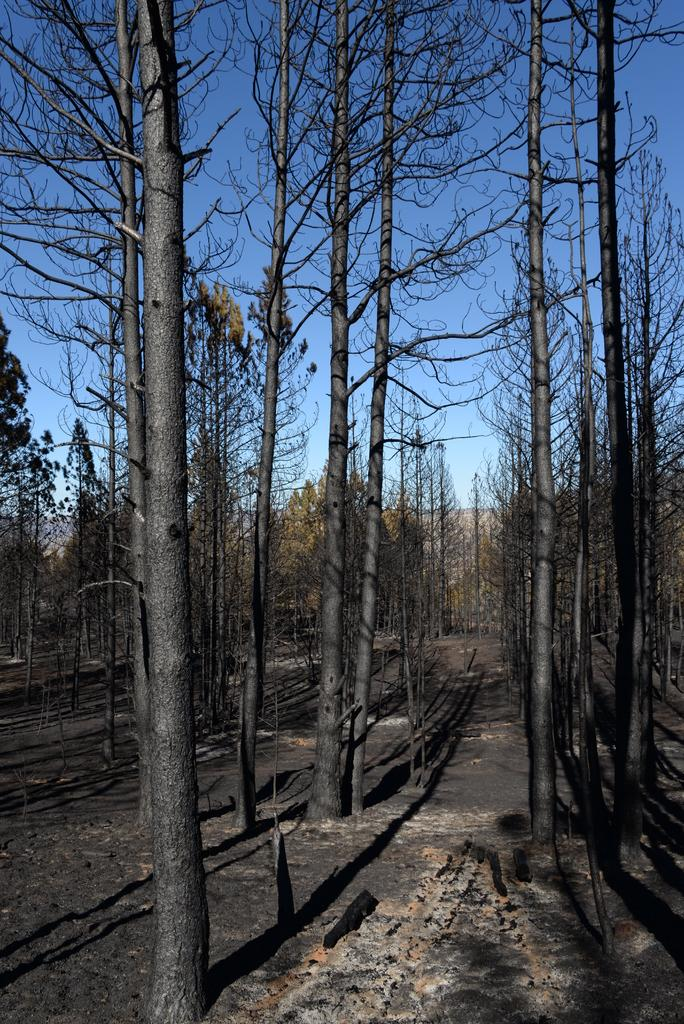What type of vegetation can be seen in the image? There are trees in the image. What part of the natural environment is visible in the image? The sky is visible in the image. What type of pipe is visible in the image? There is no pipe present in the image. What angle is the fog visible from in the image? There is no fog present in the image. 